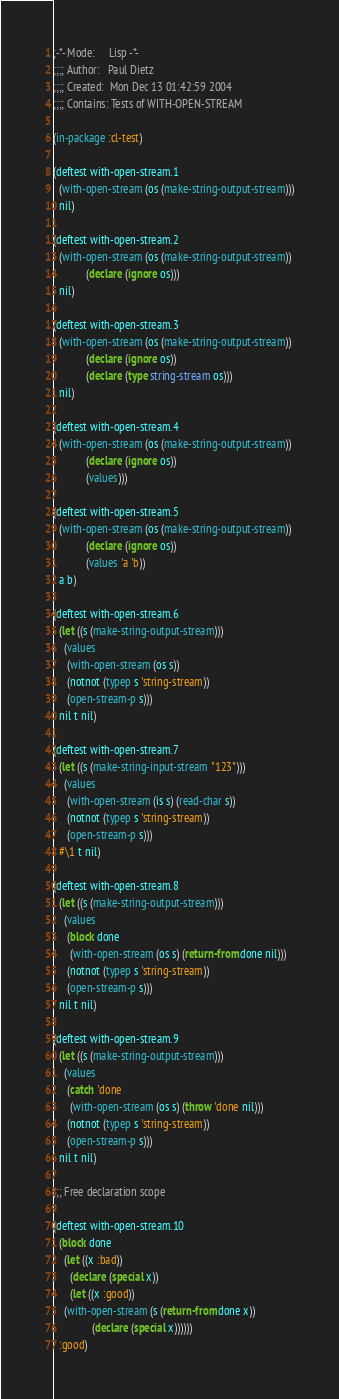Convert code to text. <code><loc_0><loc_0><loc_500><loc_500><_Lisp_>;-*- Mode:     Lisp -*-
;;;; Author:   Paul Dietz
;;;; Created:  Mon Dec 13 01:42:59 2004
;;;; Contains: Tests of WITH-OPEN-STREAM

(in-package :cl-test)

(deftest with-open-stream.1
  (with-open-stream (os (make-string-output-stream)))
  nil)

(deftest with-open-stream.2
  (with-open-stream (os (make-string-output-stream))
		    (declare (ignore os)))
  nil)

(deftest with-open-stream.3
  (with-open-stream (os (make-string-output-stream))
		    (declare (ignore os))
		    (declare (type string-stream os)))
  nil)

(deftest with-open-stream.4
  (with-open-stream (os (make-string-output-stream))
		    (declare (ignore os))
		    (values)))

(deftest with-open-stream.5
  (with-open-stream (os (make-string-output-stream))
		    (declare (ignore os))
		    (values 'a 'b))
  a b)

(deftest with-open-stream.6
  (let ((s (make-string-output-stream)))
    (values
     (with-open-stream (os s))
     (notnot (typep s 'string-stream))
     (open-stream-p s)))
  nil t nil)

(deftest with-open-stream.7
  (let ((s (make-string-input-stream "123")))
    (values
     (with-open-stream (is s) (read-char s))
     (notnot (typep s 'string-stream))
     (open-stream-p s)))
  #\1 t nil)

(deftest with-open-stream.8
  (let ((s (make-string-output-stream)))
    (values
     (block done
      (with-open-stream (os s) (return-from done nil)))
     (notnot (typep s 'string-stream))
     (open-stream-p s)))
  nil t nil)

(deftest with-open-stream.9
  (let ((s (make-string-output-stream)))
    (values
     (catch 'done
      (with-open-stream (os s) (throw 'done nil)))
     (notnot (typep s 'string-stream))
     (open-stream-p s)))
  nil t nil)

;;; Free declaration scope

(deftest with-open-stream.10
  (block done
    (let ((x :bad))
      (declare (special x))
      (let ((x :good))
	(with-open-stream (s (return-from done x))
			  (declare (special x))))))
  :good)
</code> 